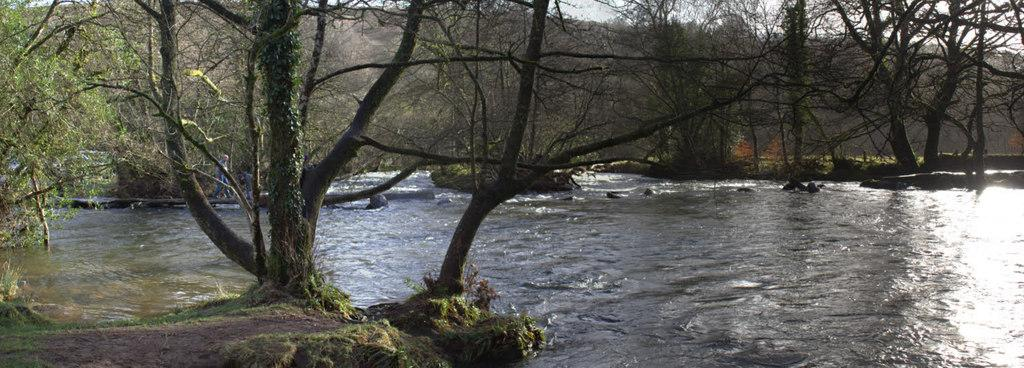What is the person in the image standing on? The person is standing on a wood log. What can be seen in the image besides the person and the log? There is water visible in the image. What type of natural environment is depicted in the background? There is a group of trees in the background. What else can be seen in the background of the image? The sky is visible in the background. What type of machine is being used for treatment in the image? There is no machine or treatment present in the image; it features a person standing on a wood log in a natural environment. 